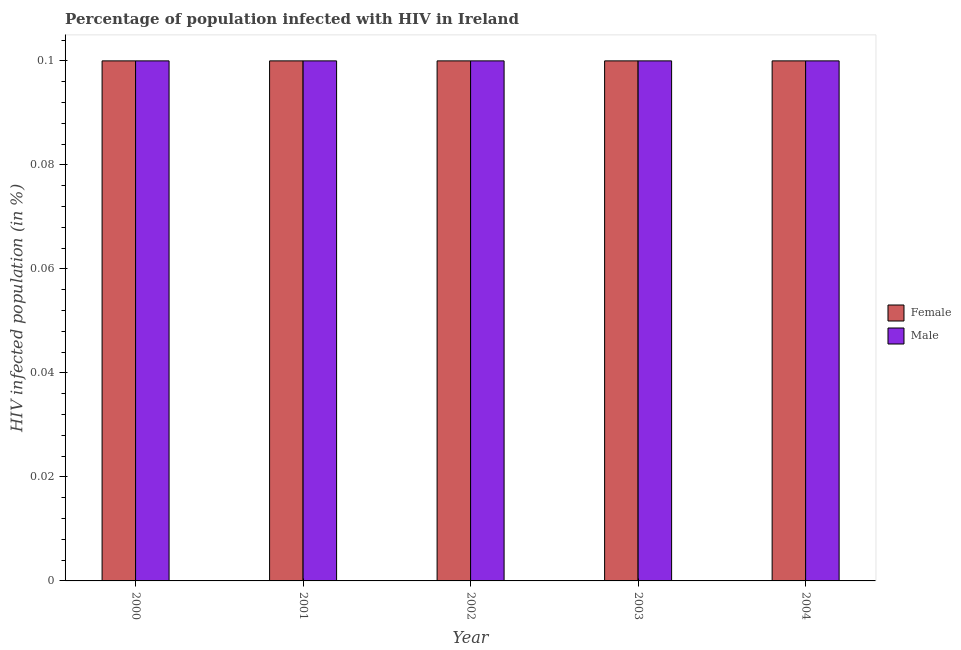Are the number of bars on each tick of the X-axis equal?
Your response must be concise. Yes. How many bars are there on the 1st tick from the right?
Make the answer very short. 2. Across all years, what is the minimum percentage of females who are infected with hiv?
Offer a terse response. 0.1. What is the total percentage of males who are infected with hiv in the graph?
Offer a very short reply. 0.5. What is the average percentage of females who are infected with hiv per year?
Your answer should be compact. 0.1. In the year 2000, what is the difference between the percentage of males who are infected with hiv and percentage of females who are infected with hiv?
Provide a succinct answer. 0. In how many years, is the percentage of males who are infected with hiv greater than 0.056 %?
Provide a short and direct response. 5. Is the percentage of males who are infected with hiv in 2002 less than that in 2003?
Provide a succinct answer. No. Is the difference between the percentage of females who are infected with hiv in 2003 and 2004 greater than the difference between the percentage of males who are infected with hiv in 2003 and 2004?
Give a very brief answer. No. What is the difference between the highest and the second highest percentage of males who are infected with hiv?
Keep it short and to the point. 0. In how many years, is the percentage of females who are infected with hiv greater than the average percentage of females who are infected with hiv taken over all years?
Offer a very short reply. 0. Is the sum of the percentage of males who are infected with hiv in 2003 and 2004 greater than the maximum percentage of females who are infected with hiv across all years?
Your response must be concise. Yes. What does the 1st bar from the left in 2001 represents?
Your answer should be very brief. Female. How many bars are there?
Ensure brevity in your answer.  10. How many years are there in the graph?
Your response must be concise. 5. Are the values on the major ticks of Y-axis written in scientific E-notation?
Offer a very short reply. No. Does the graph contain any zero values?
Offer a very short reply. No. How many legend labels are there?
Your answer should be compact. 2. How are the legend labels stacked?
Provide a short and direct response. Vertical. What is the title of the graph?
Ensure brevity in your answer.  Percentage of population infected with HIV in Ireland. Does "Female population" appear as one of the legend labels in the graph?
Keep it short and to the point. No. What is the label or title of the Y-axis?
Ensure brevity in your answer.  HIV infected population (in %). What is the HIV infected population (in %) of Female in 2000?
Provide a succinct answer. 0.1. What is the HIV infected population (in %) in Male in 2000?
Provide a succinct answer. 0.1. What is the HIV infected population (in %) in Female in 2001?
Offer a very short reply. 0.1. What is the HIV infected population (in %) in Female in 2002?
Your response must be concise. 0.1. What is the HIV infected population (in %) in Male in 2002?
Your answer should be very brief. 0.1. What is the HIV infected population (in %) in Female in 2003?
Keep it short and to the point. 0.1. What is the HIV infected population (in %) in Female in 2004?
Offer a terse response. 0.1. What is the HIV infected population (in %) of Male in 2004?
Offer a terse response. 0.1. Across all years, what is the minimum HIV infected population (in %) in Female?
Your answer should be compact. 0.1. Across all years, what is the minimum HIV infected population (in %) in Male?
Your answer should be compact. 0.1. What is the difference between the HIV infected population (in %) of Female in 2000 and that in 2001?
Offer a very short reply. 0. What is the difference between the HIV infected population (in %) in Male in 2000 and that in 2001?
Provide a short and direct response. 0. What is the difference between the HIV infected population (in %) in Male in 2000 and that in 2003?
Give a very brief answer. 0. What is the difference between the HIV infected population (in %) of Female in 2001 and that in 2002?
Give a very brief answer. 0. What is the difference between the HIV infected population (in %) of Female in 2001 and that in 2003?
Give a very brief answer. 0. What is the difference between the HIV infected population (in %) in Female in 2001 and that in 2004?
Your answer should be very brief. 0. What is the difference between the HIV infected population (in %) in Female in 2002 and that in 2003?
Your answer should be very brief. 0. What is the difference between the HIV infected population (in %) in Male in 2002 and that in 2003?
Ensure brevity in your answer.  0. What is the difference between the HIV infected population (in %) in Male in 2002 and that in 2004?
Give a very brief answer. 0. What is the difference between the HIV infected population (in %) of Male in 2003 and that in 2004?
Offer a terse response. 0. What is the difference between the HIV infected population (in %) in Female in 2000 and the HIV infected population (in %) in Male in 2002?
Provide a short and direct response. 0. What is the difference between the HIV infected population (in %) of Female in 2000 and the HIV infected population (in %) of Male in 2003?
Keep it short and to the point. 0. What is the difference between the HIV infected population (in %) of Female in 2001 and the HIV infected population (in %) of Male in 2003?
Give a very brief answer. 0. What is the difference between the HIV infected population (in %) in Female in 2002 and the HIV infected population (in %) in Male in 2004?
Your answer should be very brief. 0. What is the difference between the HIV infected population (in %) in Female in 2003 and the HIV infected population (in %) in Male in 2004?
Give a very brief answer. 0. What is the average HIV infected population (in %) in Female per year?
Your answer should be very brief. 0.1. What is the average HIV infected population (in %) in Male per year?
Provide a succinct answer. 0.1. In the year 2000, what is the difference between the HIV infected population (in %) of Female and HIV infected population (in %) of Male?
Offer a very short reply. 0. In the year 2003, what is the difference between the HIV infected population (in %) of Female and HIV infected population (in %) of Male?
Provide a succinct answer. 0. What is the ratio of the HIV infected population (in %) of Female in 2000 to that in 2001?
Keep it short and to the point. 1. What is the ratio of the HIV infected population (in %) of Male in 2000 to that in 2002?
Ensure brevity in your answer.  1. What is the ratio of the HIV infected population (in %) in Male in 2000 to that in 2004?
Provide a succinct answer. 1. What is the ratio of the HIV infected population (in %) in Female in 2001 to that in 2002?
Make the answer very short. 1. What is the ratio of the HIV infected population (in %) in Female in 2001 to that in 2004?
Your answer should be very brief. 1. What is the ratio of the HIV infected population (in %) in Male in 2002 to that in 2003?
Provide a short and direct response. 1. What is the ratio of the HIV infected population (in %) of Female in 2002 to that in 2004?
Your answer should be very brief. 1. What is the ratio of the HIV infected population (in %) of Male in 2003 to that in 2004?
Ensure brevity in your answer.  1. What is the difference between the highest and the second highest HIV infected population (in %) of Female?
Keep it short and to the point. 0. What is the difference between the highest and the second highest HIV infected population (in %) in Male?
Give a very brief answer. 0. What is the difference between the highest and the lowest HIV infected population (in %) in Male?
Provide a succinct answer. 0. 